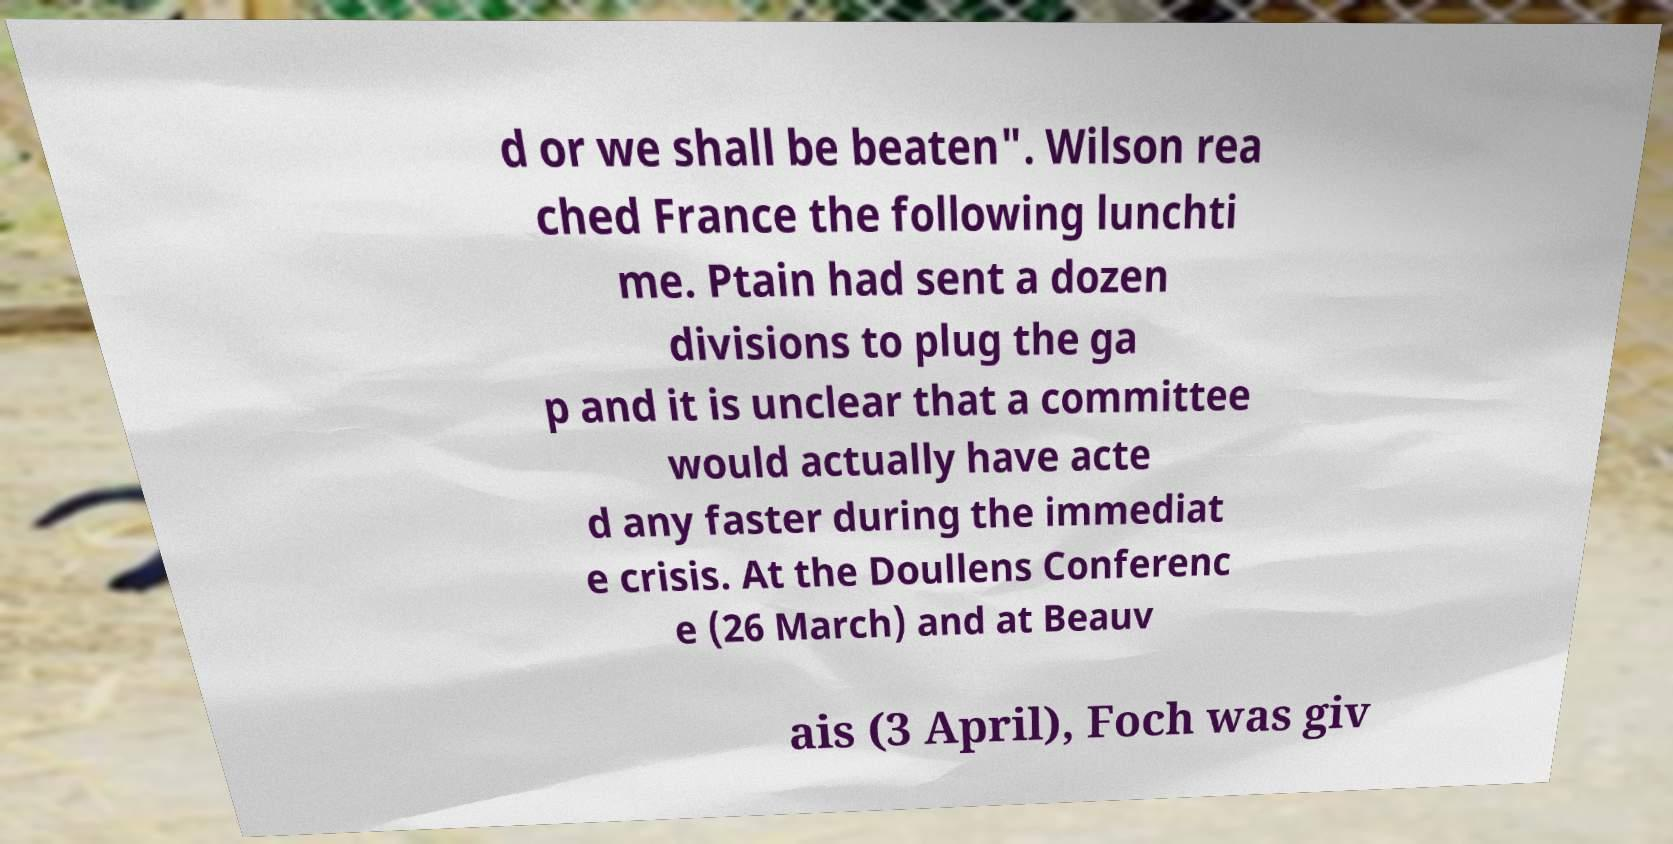Please identify and transcribe the text found in this image. d or we shall be beaten". Wilson rea ched France the following lunchti me. Ptain had sent a dozen divisions to plug the ga p and it is unclear that a committee would actually have acte d any faster during the immediat e crisis. At the Doullens Conferenc e (26 March) and at Beauv ais (3 April), Foch was giv 